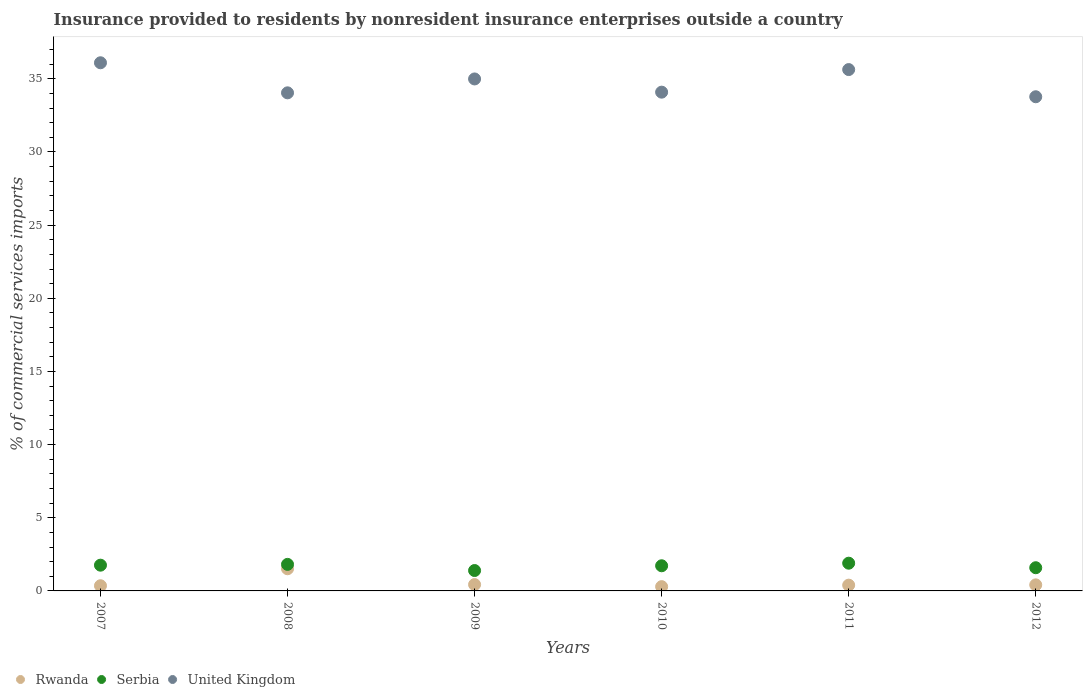Is the number of dotlines equal to the number of legend labels?
Your answer should be compact. Yes. What is the Insurance provided to residents in Rwanda in 2009?
Keep it short and to the point. 0.43. Across all years, what is the maximum Insurance provided to residents in United Kingdom?
Provide a succinct answer. 36.1. Across all years, what is the minimum Insurance provided to residents in Rwanda?
Make the answer very short. 0.29. In which year was the Insurance provided to residents in United Kingdom minimum?
Ensure brevity in your answer.  2012. What is the total Insurance provided to residents in Serbia in the graph?
Make the answer very short. 10.17. What is the difference between the Insurance provided to residents in Rwanda in 2008 and that in 2010?
Keep it short and to the point. 1.22. What is the difference between the Insurance provided to residents in Rwanda in 2009 and the Insurance provided to residents in Serbia in 2010?
Provide a short and direct response. -1.29. What is the average Insurance provided to residents in United Kingdom per year?
Keep it short and to the point. 34.77. In the year 2007, what is the difference between the Insurance provided to residents in Rwanda and Insurance provided to residents in Serbia?
Your response must be concise. -1.41. What is the ratio of the Insurance provided to residents in United Kingdom in 2008 to that in 2009?
Keep it short and to the point. 0.97. What is the difference between the highest and the second highest Insurance provided to residents in United Kingdom?
Provide a succinct answer. 0.47. What is the difference between the highest and the lowest Insurance provided to residents in Rwanda?
Ensure brevity in your answer.  1.22. In how many years, is the Insurance provided to residents in Rwanda greater than the average Insurance provided to residents in Rwanda taken over all years?
Ensure brevity in your answer.  1. Is the sum of the Insurance provided to residents in Serbia in 2007 and 2008 greater than the maximum Insurance provided to residents in Rwanda across all years?
Provide a short and direct response. Yes. Is it the case that in every year, the sum of the Insurance provided to residents in United Kingdom and Insurance provided to residents in Serbia  is greater than the Insurance provided to residents in Rwanda?
Offer a terse response. Yes. Is the Insurance provided to residents in Serbia strictly less than the Insurance provided to residents in United Kingdom over the years?
Provide a short and direct response. Yes. What is the difference between two consecutive major ticks on the Y-axis?
Offer a terse response. 5. Are the values on the major ticks of Y-axis written in scientific E-notation?
Provide a short and direct response. No. What is the title of the graph?
Give a very brief answer. Insurance provided to residents by nonresident insurance enterprises outside a country. What is the label or title of the X-axis?
Offer a very short reply. Years. What is the label or title of the Y-axis?
Offer a very short reply. % of commercial services imports. What is the % of commercial services imports of Rwanda in 2007?
Offer a very short reply. 0.35. What is the % of commercial services imports in Serbia in 2007?
Offer a very short reply. 1.76. What is the % of commercial services imports of United Kingdom in 2007?
Keep it short and to the point. 36.1. What is the % of commercial services imports in Rwanda in 2008?
Give a very brief answer. 1.51. What is the % of commercial services imports of Serbia in 2008?
Ensure brevity in your answer.  1.81. What is the % of commercial services imports in United Kingdom in 2008?
Give a very brief answer. 34.04. What is the % of commercial services imports in Rwanda in 2009?
Your answer should be very brief. 0.43. What is the % of commercial services imports of Serbia in 2009?
Your answer should be compact. 1.39. What is the % of commercial services imports of United Kingdom in 2009?
Your response must be concise. 34.99. What is the % of commercial services imports of Rwanda in 2010?
Your response must be concise. 0.29. What is the % of commercial services imports in Serbia in 2010?
Your answer should be compact. 1.72. What is the % of commercial services imports of United Kingdom in 2010?
Your response must be concise. 34.09. What is the % of commercial services imports of Rwanda in 2011?
Offer a terse response. 0.4. What is the % of commercial services imports of Serbia in 2011?
Your answer should be compact. 1.9. What is the % of commercial services imports of United Kingdom in 2011?
Your answer should be compact. 35.63. What is the % of commercial services imports of Rwanda in 2012?
Ensure brevity in your answer.  0.41. What is the % of commercial services imports in Serbia in 2012?
Your response must be concise. 1.59. What is the % of commercial services imports in United Kingdom in 2012?
Give a very brief answer. 33.77. Across all years, what is the maximum % of commercial services imports in Rwanda?
Your answer should be compact. 1.51. Across all years, what is the maximum % of commercial services imports in Serbia?
Your answer should be compact. 1.9. Across all years, what is the maximum % of commercial services imports in United Kingdom?
Offer a terse response. 36.1. Across all years, what is the minimum % of commercial services imports in Rwanda?
Make the answer very short. 0.29. Across all years, what is the minimum % of commercial services imports of Serbia?
Your answer should be compact. 1.39. Across all years, what is the minimum % of commercial services imports of United Kingdom?
Your answer should be very brief. 33.77. What is the total % of commercial services imports in Rwanda in the graph?
Offer a terse response. 3.4. What is the total % of commercial services imports of Serbia in the graph?
Offer a very short reply. 10.17. What is the total % of commercial services imports of United Kingdom in the graph?
Keep it short and to the point. 208.63. What is the difference between the % of commercial services imports of Rwanda in 2007 and that in 2008?
Give a very brief answer. -1.16. What is the difference between the % of commercial services imports in Serbia in 2007 and that in 2008?
Keep it short and to the point. -0.05. What is the difference between the % of commercial services imports in United Kingdom in 2007 and that in 2008?
Your answer should be very brief. 2.06. What is the difference between the % of commercial services imports of Rwanda in 2007 and that in 2009?
Make the answer very short. -0.08. What is the difference between the % of commercial services imports in Serbia in 2007 and that in 2009?
Your response must be concise. 0.37. What is the difference between the % of commercial services imports in United Kingdom in 2007 and that in 2009?
Keep it short and to the point. 1.11. What is the difference between the % of commercial services imports in Rwanda in 2007 and that in 2010?
Ensure brevity in your answer.  0.06. What is the difference between the % of commercial services imports of Serbia in 2007 and that in 2010?
Provide a short and direct response. 0.04. What is the difference between the % of commercial services imports of United Kingdom in 2007 and that in 2010?
Make the answer very short. 2.01. What is the difference between the % of commercial services imports of Rwanda in 2007 and that in 2011?
Offer a very short reply. -0.04. What is the difference between the % of commercial services imports in Serbia in 2007 and that in 2011?
Give a very brief answer. -0.14. What is the difference between the % of commercial services imports of United Kingdom in 2007 and that in 2011?
Give a very brief answer. 0.47. What is the difference between the % of commercial services imports in Rwanda in 2007 and that in 2012?
Provide a short and direct response. -0.06. What is the difference between the % of commercial services imports of Serbia in 2007 and that in 2012?
Your answer should be compact. 0.17. What is the difference between the % of commercial services imports in United Kingdom in 2007 and that in 2012?
Your answer should be compact. 2.32. What is the difference between the % of commercial services imports of Rwanda in 2008 and that in 2009?
Give a very brief answer. 1.08. What is the difference between the % of commercial services imports of Serbia in 2008 and that in 2009?
Make the answer very short. 0.42. What is the difference between the % of commercial services imports in United Kingdom in 2008 and that in 2009?
Your response must be concise. -0.95. What is the difference between the % of commercial services imports of Rwanda in 2008 and that in 2010?
Offer a terse response. 1.22. What is the difference between the % of commercial services imports of Serbia in 2008 and that in 2010?
Your answer should be compact. 0.1. What is the difference between the % of commercial services imports in United Kingdom in 2008 and that in 2010?
Your answer should be very brief. -0.05. What is the difference between the % of commercial services imports in Rwanda in 2008 and that in 2011?
Give a very brief answer. 1.12. What is the difference between the % of commercial services imports in Serbia in 2008 and that in 2011?
Offer a very short reply. -0.08. What is the difference between the % of commercial services imports in United Kingdom in 2008 and that in 2011?
Your answer should be very brief. -1.59. What is the difference between the % of commercial services imports in Rwanda in 2008 and that in 2012?
Keep it short and to the point. 1.1. What is the difference between the % of commercial services imports of Serbia in 2008 and that in 2012?
Offer a terse response. 0.23. What is the difference between the % of commercial services imports of United Kingdom in 2008 and that in 2012?
Provide a short and direct response. 0.27. What is the difference between the % of commercial services imports of Rwanda in 2009 and that in 2010?
Make the answer very short. 0.14. What is the difference between the % of commercial services imports in Serbia in 2009 and that in 2010?
Your answer should be compact. -0.33. What is the difference between the % of commercial services imports in United Kingdom in 2009 and that in 2010?
Keep it short and to the point. 0.9. What is the difference between the % of commercial services imports of Rwanda in 2009 and that in 2011?
Provide a short and direct response. 0.04. What is the difference between the % of commercial services imports in Serbia in 2009 and that in 2011?
Give a very brief answer. -0.5. What is the difference between the % of commercial services imports of United Kingdom in 2009 and that in 2011?
Provide a short and direct response. -0.64. What is the difference between the % of commercial services imports in Rwanda in 2009 and that in 2012?
Your answer should be very brief. 0.02. What is the difference between the % of commercial services imports in Serbia in 2009 and that in 2012?
Offer a very short reply. -0.19. What is the difference between the % of commercial services imports in United Kingdom in 2009 and that in 2012?
Ensure brevity in your answer.  1.22. What is the difference between the % of commercial services imports in Rwanda in 2010 and that in 2011?
Offer a very short reply. -0.1. What is the difference between the % of commercial services imports in Serbia in 2010 and that in 2011?
Provide a succinct answer. -0.18. What is the difference between the % of commercial services imports of United Kingdom in 2010 and that in 2011?
Ensure brevity in your answer.  -1.54. What is the difference between the % of commercial services imports in Rwanda in 2010 and that in 2012?
Ensure brevity in your answer.  -0.12. What is the difference between the % of commercial services imports of Serbia in 2010 and that in 2012?
Make the answer very short. 0.13. What is the difference between the % of commercial services imports of United Kingdom in 2010 and that in 2012?
Offer a very short reply. 0.31. What is the difference between the % of commercial services imports of Rwanda in 2011 and that in 2012?
Your answer should be very brief. -0.02. What is the difference between the % of commercial services imports in Serbia in 2011 and that in 2012?
Your answer should be very brief. 0.31. What is the difference between the % of commercial services imports of United Kingdom in 2011 and that in 2012?
Offer a terse response. 1.86. What is the difference between the % of commercial services imports of Rwanda in 2007 and the % of commercial services imports of Serbia in 2008?
Make the answer very short. -1.46. What is the difference between the % of commercial services imports in Rwanda in 2007 and the % of commercial services imports in United Kingdom in 2008?
Your answer should be very brief. -33.69. What is the difference between the % of commercial services imports in Serbia in 2007 and the % of commercial services imports in United Kingdom in 2008?
Your answer should be very brief. -32.28. What is the difference between the % of commercial services imports in Rwanda in 2007 and the % of commercial services imports in Serbia in 2009?
Offer a very short reply. -1.04. What is the difference between the % of commercial services imports in Rwanda in 2007 and the % of commercial services imports in United Kingdom in 2009?
Make the answer very short. -34.64. What is the difference between the % of commercial services imports of Serbia in 2007 and the % of commercial services imports of United Kingdom in 2009?
Make the answer very short. -33.23. What is the difference between the % of commercial services imports in Rwanda in 2007 and the % of commercial services imports in Serbia in 2010?
Provide a short and direct response. -1.36. What is the difference between the % of commercial services imports of Rwanda in 2007 and the % of commercial services imports of United Kingdom in 2010?
Provide a succinct answer. -33.73. What is the difference between the % of commercial services imports in Serbia in 2007 and the % of commercial services imports in United Kingdom in 2010?
Keep it short and to the point. -32.33. What is the difference between the % of commercial services imports in Rwanda in 2007 and the % of commercial services imports in Serbia in 2011?
Provide a short and direct response. -1.54. What is the difference between the % of commercial services imports of Rwanda in 2007 and the % of commercial services imports of United Kingdom in 2011?
Offer a terse response. -35.28. What is the difference between the % of commercial services imports in Serbia in 2007 and the % of commercial services imports in United Kingdom in 2011?
Give a very brief answer. -33.87. What is the difference between the % of commercial services imports of Rwanda in 2007 and the % of commercial services imports of Serbia in 2012?
Ensure brevity in your answer.  -1.23. What is the difference between the % of commercial services imports in Rwanda in 2007 and the % of commercial services imports in United Kingdom in 2012?
Give a very brief answer. -33.42. What is the difference between the % of commercial services imports of Serbia in 2007 and the % of commercial services imports of United Kingdom in 2012?
Make the answer very short. -32.02. What is the difference between the % of commercial services imports in Rwanda in 2008 and the % of commercial services imports in Serbia in 2009?
Offer a very short reply. 0.12. What is the difference between the % of commercial services imports in Rwanda in 2008 and the % of commercial services imports in United Kingdom in 2009?
Offer a very short reply. -33.48. What is the difference between the % of commercial services imports of Serbia in 2008 and the % of commercial services imports of United Kingdom in 2009?
Make the answer very short. -33.18. What is the difference between the % of commercial services imports in Rwanda in 2008 and the % of commercial services imports in Serbia in 2010?
Your answer should be very brief. -0.2. What is the difference between the % of commercial services imports in Rwanda in 2008 and the % of commercial services imports in United Kingdom in 2010?
Your answer should be compact. -32.57. What is the difference between the % of commercial services imports in Serbia in 2008 and the % of commercial services imports in United Kingdom in 2010?
Your response must be concise. -32.27. What is the difference between the % of commercial services imports of Rwanda in 2008 and the % of commercial services imports of Serbia in 2011?
Keep it short and to the point. -0.38. What is the difference between the % of commercial services imports of Rwanda in 2008 and the % of commercial services imports of United Kingdom in 2011?
Your response must be concise. -34.12. What is the difference between the % of commercial services imports of Serbia in 2008 and the % of commercial services imports of United Kingdom in 2011?
Give a very brief answer. -33.82. What is the difference between the % of commercial services imports in Rwanda in 2008 and the % of commercial services imports in Serbia in 2012?
Your answer should be very brief. -0.07. What is the difference between the % of commercial services imports of Rwanda in 2008 and the % of commercial services imports of United Kingdom in 2012?
Provide a succinct answer. -32.26. What is the difference between the % of commercial services imports of Serbia in 2008 and the % of commercial services imports of United Kingdom in 2012?
Give a very brief answer. -31.96. What is the difference between the % of commercial services imports of Rwanda in 2009 and the % of commercial services imports of Serbia in 2010?
Provide a succinct answer. -1.29. What is the difference between the % of commercial services imports in Rwanda in 2009 and the % of commercial services imports in United Kingdom in 2010?
Your answer should be compact. -33.66. What is the difference between the % of commercial services imports of Serbia in 2009 and the % of commercial services imports of United Kingdom in 2010?
Keep it short and to the point. -32.7. What is the difference between the % of commercial services imports in Rwanda in 2009 and the % of commercial services imports in Serbia in 2011?
Provide a succinct answer. -1.46. What is the difference between the % of commercial services imports of Rwanda in 2009 and the % of commercial services imports of United Kingdom in 2011?
Keep it short and to the point. -35.2. What is the difference between the % of commercial services imports of Serbia in 2009 and the % of commercial services imports of United Kingdom in 2011?
Offer a terse response. -34.24. What is the difference between the % of commercial services imports in Rwanda in 2009 and the % of commercial services imports in Serbia in 2012?
Offer a terse response. -1.15. What is the difference between the % of commercial services imports in Rwanda in 2009 and the % of commercial services imports in United Kingdom in 2012?
Offer a very short reply. -33.34. What is the difference between the % of commercial services imports of Serbia in 2009 and the % of commercial services imports of United Kingdom in 2012?
Offer a very short reply. -32.38. What is the difference between the % of commercial services imports in Rwanda in 2010 and the % of commercial services imports in Serbia in 2011?
Make the answer very short. -1.6. What is the difference between the % of commercial services imports in Rwanda in 2010 and the % of commercial services imports in United Kingdom in 2011?
Make the answer very short. -35.34. What is the difference between the % of commercial services imports in Serbia in 2010 and the % of commercial services imports in United Kingdom in 2011?
Ensure brevity in your answer.  -33.91. What is the difference between the % of commercial services imports in Rwanda in 2010 and the % of commercial services imports in Serbia in 2012?
Provide a short and direct response. -1.29. What is the difference between the % of commercial services imports of Rwanda in 2010 and the % of commercial services imports of United Kingdom in 2012?
Offer a terse response. -33.48. What is the difference between the % of commercial services imports in Serbia in 2010 and the % of commercial services imports in United Kingdom in 2012?
Ensure brevity in your answer.  -32.06. What is the difference between the % of commercial services imports in Rwanda in 2011 and the % of commercial services imports in Serbia in 2012?
Ensure brevity in your answer.  -1.19. What is the difference between the % of commercial services imports in Rwanda in 2011 and the % of commercial services imports in United Kingdom in 2012?
Offer a very short reply. -33.38. What is the difference between the % of commercial services imports of Serbia in 2011 and the % of commercial services imports of United Kingdom in 2012?
Give a very brief answer. -31.88. What is the average % of commercial services imports of Rwanda per year?
Your response must be concise. 0.57. What is the average % of commercial services imports of Serbia per year?
Keep it short and to the point. 1.69. What is the average % of commercial services imports of United Kingdom per year?
Ensure brevity in your answer.  34.77. In the year 2007, what is the difference between the % of commercial services imports of Rwanda and % of commercial services imports of Serbia?
Your response must be concise. -1.41. In the year 2007, what is the difference between the % of commercial services imports in Rwanda and % of commercial services imports in United Kingdom?
Ensure brevity in your answer.  -35.74. In the year 2007, what is the difference between the % of commercial services imports in Serbia and % of commercial services imports in United Kingdom?
Give a very brief answer. -34.34. In the year 2008, what is the difference between the % of commercial services imports in Rwanda and % of commercial services imports in Serbia?
Offer a terse response. -0.3. In the year 2008, what is the difference between the % of commercial services imports in Rwanda and % of commercial services imports in United Kingdom?
Offer a terse response. -32.53. In the year 2008, what is the difference between the % of commercial services imports in Serbia and % of commercial services imports in United Kingdom?
Your answer should be compact. -32.23. In the year 2009, what is the difference between the % of commercial services imports in Rwanda and % of commercial services imports in Serbia?
Your answer should be very brief. -0.96. In the year 2009, what is the difference between the % of commercial services imports in Rwanda and % of commercial services imports in United Kingdom?
Your response must be concise. -34.56. In the year 2009, what is the difference between the % of commercial services imports of Serbia and % of commercial services imports of United Kingdom?
Your answer should be compact. -33.6. In the year 2010, what is the difference between the % of commercial services imports in Rwanda and % of commercial services imports in Serbia?
Provide a short and direct response. -1.43. In the year 2010, what is the difference between the % of commercial services imports in Rwanda and % of commercial services imports in United Kingdom?
Your answer should be very brief. -33.8. In the year 2010, what is the difference between the % of commercial services imports of Serbia and % of commercial services imports of United Kingdom?
Make the answer very short. -32.37. In the year 2011, what is the difference between the % of commercial services imports of Rwanda and % of commercial services imports of Serbia?
Offer a terse response. -1.5. In the year 2011, what is the difference between the % of commercial services imports of Rwanda and % of commercial services imports of United Kingdom?
Your answer should be very brief. -35.24. In the year 2011, what is the difference between the % of commercial services imports of Serbia and % of commercial services imports of United Kingdom?
Offer a very short reply. -33.74. In the year 2012, what is the difference between the % of commercial services imports in Rwanda and % of commercial services imports in Serbia?
Keep it short and to the point. -1.17. In the year 2012, what is the difference between the % of commercial services imports in Rwanda and % of commercial services imports in United Kingdom?
Provide a succinct answer. -33.36. In the year 2012, what is the difference between the % of commercial services imports in Serbia and % of commercial services imports in United Kingdom?
Keep it short and to the point. -32.19. What is the ratio of the % of commercial services imports in Rwanda in 2007 to that in 2008?
Ensure brevity in your answer.  0.23. What is the ratio of the % of commercial services imports of Serbia in 2007 to that in 2008?
Keep it short and to the point. 0.97. What is the ratio of the % of commercial services imports in United Kingdom in 2007 to that in 2008?
Offer a terse response. 1.06. What is the ratio of the % of commercial services imports of Rwanda in 2007 to that in 2009?
Offer a very short reply. 0.82. What is the ratio of the % of commercial services imports of Serbia in 2007 to that in 2009?
Your response must be concise. 1.26. What is the ratio of the % of commercial services imports of United Kingdom in 2007 to that in 2009?
Offer a very short reply. 1.03. What is the ratio of the % of commercial services imports of Rwanda in 2007 to that in 2010?
Your answer should be compact. 1.21. What is the ratio of the % of commercial services imports of Serbia in 2007 to that in 2010?
Your response must be concise. 1.02. What is the ratio of the % of commercial services imports of United Kingdom in 2007 to that in 2010?
Provide a short and direct response. 1.06. What is the ratio of the % of commercial services imports of Rwanda in 2007 to that in 2011?
Ensure brevity in your answer.  0.9. What is the ratio of the % of commercial services imports in Serbia in 2007 to that in 2011?
Your response must be concise. 0.93. What is the ratio of the % of commercial services imports in United Kingdom in 2007 to that in 2011?
Your response must be concise. 1.01. What is the ratio of the % of commercial services imports in Rwanda in 2007 to that in 2012?
Give a very brief answer. 0.86. What is the ratio of the % of commercial services imports of Serbia in 2007 to that in 2012?
Your answer should be very brief. 1.11. What is the ratio of the % of commercial services imports of United Kingdom in 2007 to that in 2012?
Ensure brevity in your answer.  1.07. What is the ratio of the % of commercial services imports of Rwanda in 2008 to that in 2009?
Offer a very short reply. 3.49. What is the ratio of the % of commercial services imports in Serbia in 2008 to that in 2009?
Your response must be concise. 1.3. What is the ratio of the % of commercial services imports of United Kingdom in 2008 to that in 2009?
Keep it short and to the point. 0.97. What is the ratio of the % of commercial services imports in Rwanda in 2008 to that in 2010?
Offer a terse response. 5.18. What is the ratio of the % of commercial services imports of Serbia in 2008 to that in 2010?
Offer a very short reply. 1.06. What is the ratio of the % of commercial services imports of United Kingdom in 2008 to that in 2010?
Provide a succinct answer. 1. What is the ratio of the % of commercial services imports in Rwanda in 2008 to that in 2011?
Ensure brevity in your answer.  3.83. What is the ratio of the % of commercial services imports in Serbia in 2008 to that in 2011?
Provide a short and direct response. 0.96. What is the ratio of the % of commercial services imports of United Kingdom in 2008 to that in 2011?
Offer a very short reply. 0.96. What is the ratio of the % of commercial services imports in Rwanda in 2008 to that in 2012?
Your response must be concise. 3.66. What is the ratio of the % of commercial services imports in Serbia in 2008 to that in 2012?
Ensure brevity in your answer.  1.14. What is the ratio of the % of commercial services imports in United Kingdom in 2008 to that in 2012?
Keep it short and to the point. 1.01. What is the ratio of the % of commercial services imports of Rwanda in 2009 to that in 2010?
Offer a terse response. 1.48. What is the ratio of the % of commercial services imports in Serbia in 2009 to that in 2010?
Provide a succinct answer. 0.81. What is the ratio of the % of commercial services imports in United Kingdom in 2009 to that in 2010?
Provide a succinct answer. 1.03. What is the ratio of the % of commercial services imports in Rwanda in 2009 to that in 2011?
Keep it short and to the point. 1.1. What is the ratio of the % of commercial services imports in Serbia in 2009 to that in 2011?
Keep it short and to the point. 0.74. What is the ratio of the % of commercial services imports in United Kingdom in 2009 to that in 2011?
Your answer should be very brief. 0.98. What is the ratio of the % of commercial services imports of Rwanda in 2009 to that in 2012?
Make the answer very short. 1.05. What is the ratio of the % of commercial services imports in Serbia in 2009 to that in 2012?
Your answer should be compact. 0.88. What is the ratio of the % of commercial services imports in United Kingdom in 2009 to that in 2012?
Offer a very short reply. 1.04. What is the ratio of the % of commercial services imports of Rwanda in 2010 to that in 2011?
Your answer should be very brief. 0.74. What is the ratio of the % of commercial services imports of Serbia in 2010 to that in 2011?
Offer a terse response. 0.91. What is the ratio of the % of commercial services imports of United Kingdom in 2010 to that in 2011?
Your response must be concise. 0.96. What is the ratio of the % of commercial services imports of Rwanda in 2010 to that in 2012?
Your answer should be very brief. 0.71. What is the ratio of the % of commercial services imports in Serbia in 2010 to that in 2012?
Provide a succinct answer. 1.08. What is the ratio of the % of commercial services imports of United Kingdom in 2010 to that in 2012?
Your answer should be compact. 1.01. What is the ratio of the % of commercial services imports in Rwanda in 2011 to that in 2012?
Make the answer very short. 0.95. What is the ratio of the % of commercial services imports of Serbia in 2011 to that in 2012?
Make the answer very short. 1.2. What is the ratio of the % of commercial services imports in United Kingdom in 2011 to that in 2012?
Make the answer very short. 1.05. What is the difference between the highest and the second highest % of commercial services imports of Rwanda?
Make the answer very short. 1.08. What is the difference between the highest and the second highest % of commercial services imports of Serbia?
Offer a very short reply. 0.08. What is the difference between the highest and the second highest % of commercial services imports in United Kingdom?
Offer a terse response. 0.47. What is the difference between the highest and the lowest % of commercial services imports of Rwanda?
Give a very brief answer. 1.22. What is the difference between the highest and the lowest % of commercial services imports of Serbia?
Offer a very short reply. 0.5. What is the difference between the highest and the lowest % of commercial services imports of United Kingdom?
Give a very brief answer. 2.32. 